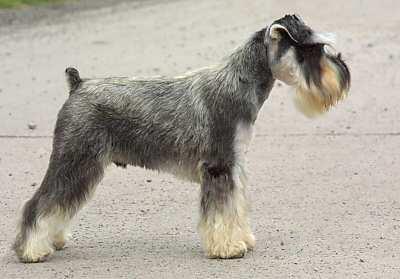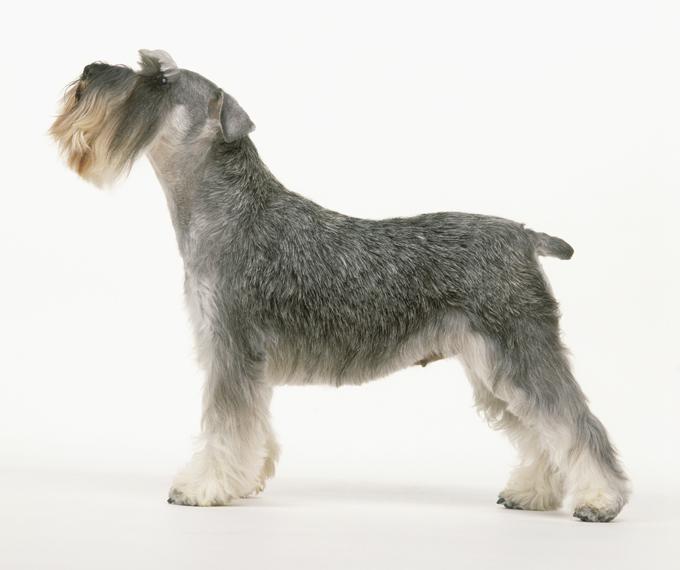The first image is the image on the left, the second image is the image on the right. Given the left and right images, does the statement "The dog in the left image is facing towards the right." hold true? Answer yes or no. Yes. The first image is the image on the left, the second image is the image on the right. Assess this claim about the two images: "AT least one dog is wearing a collar.". Correct or not? Answer yes or no. No. 